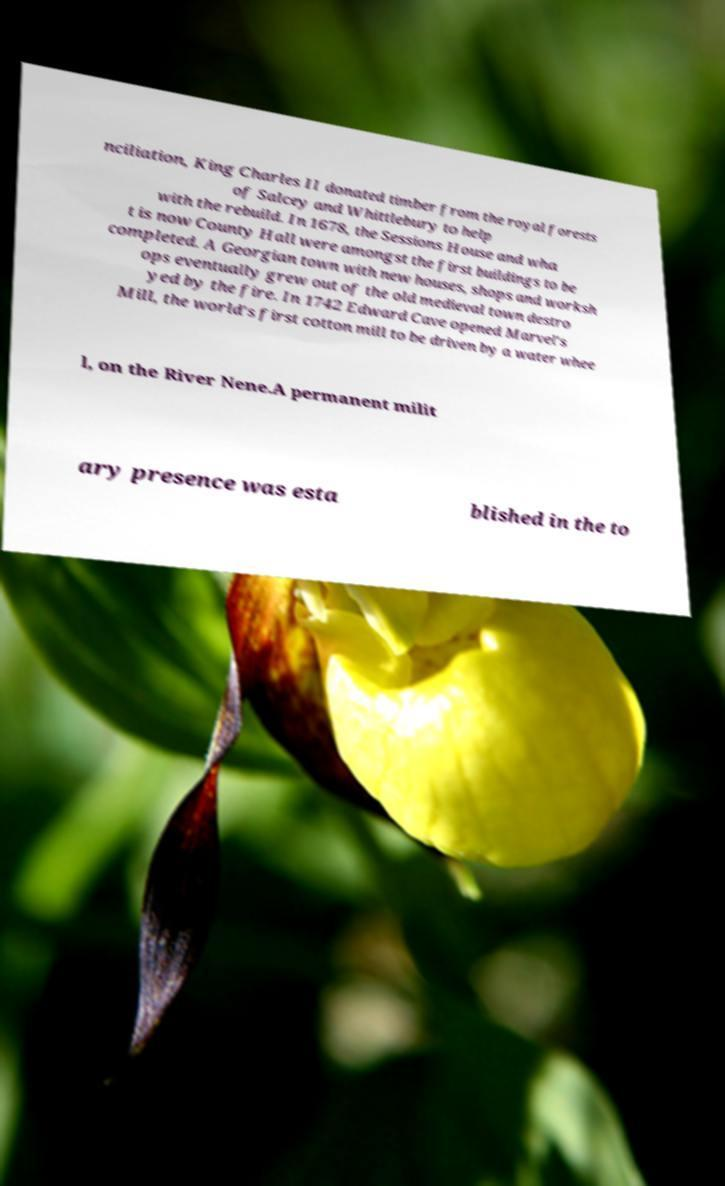Could you assist in decoding the text presented in this image and type it out clearly? nciliation, King Charles II donated timber from the royal forests of Salcey and Whittlebury to help with the rebuild. In 1678, the Sessions House and wha t is now County Hall were amongst the first buildings to be completed. A Georgian town with new houses, shops and worksh ops eventually grew out of the old medieval town destro yed by the fire. In 1742 Edward Cave opened Marvel's Mill, the world's first cotton mill to be driven by a water whee l, on the River Nene.A permanent milit ary presence was esta blished in the to 